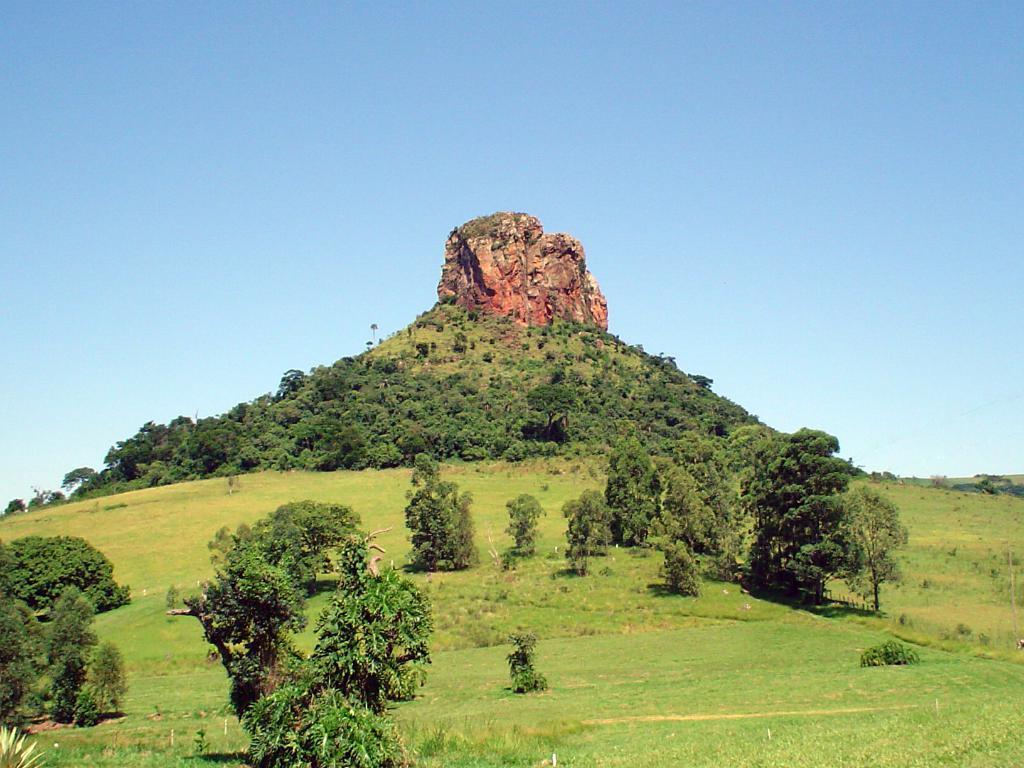Could you give a brief overview of what you see in this image? This image is clicked on the hill. There are trees and grass on the hill. In the center there is a rock on the hill. At the top there is the sky. 